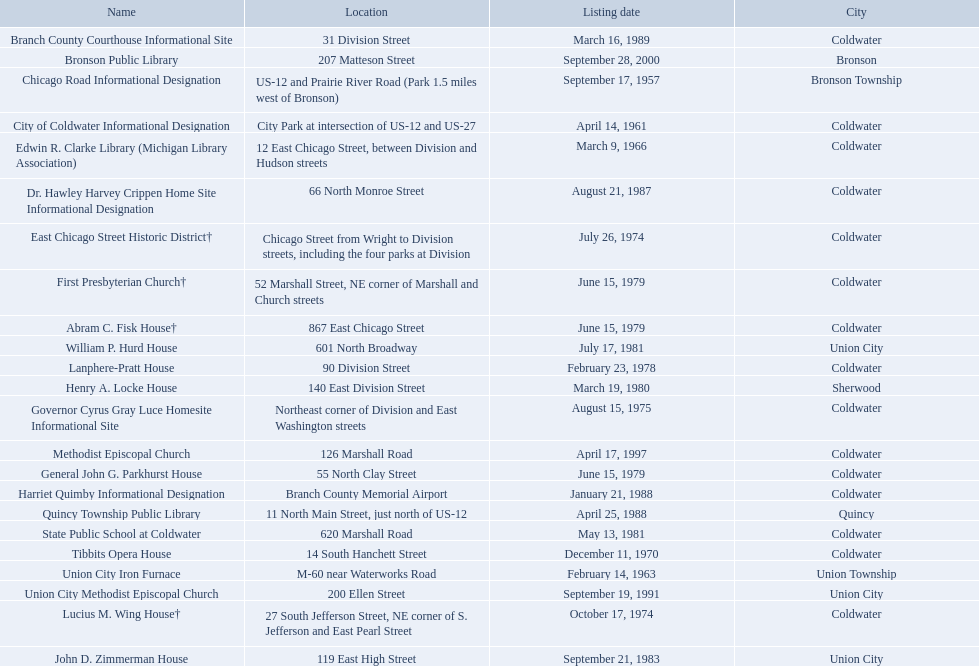Are there any listing dates that happened before 1960? September 17, 1957. What is the name of the site that was listed before 1960? Chicago Road Informational Designation. 